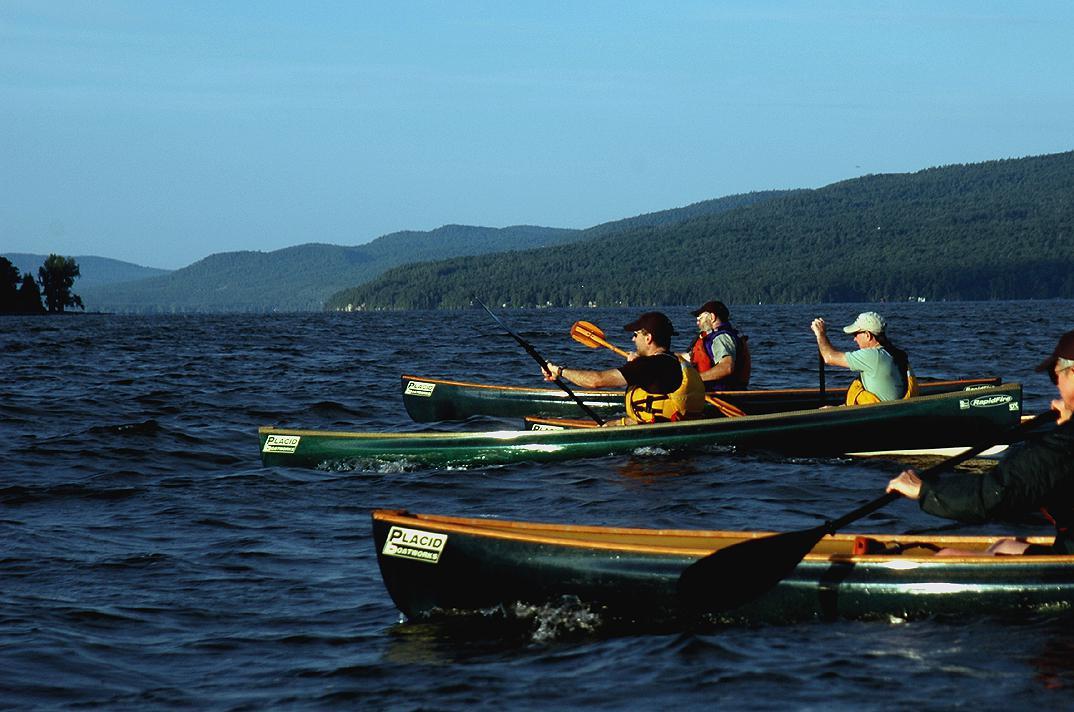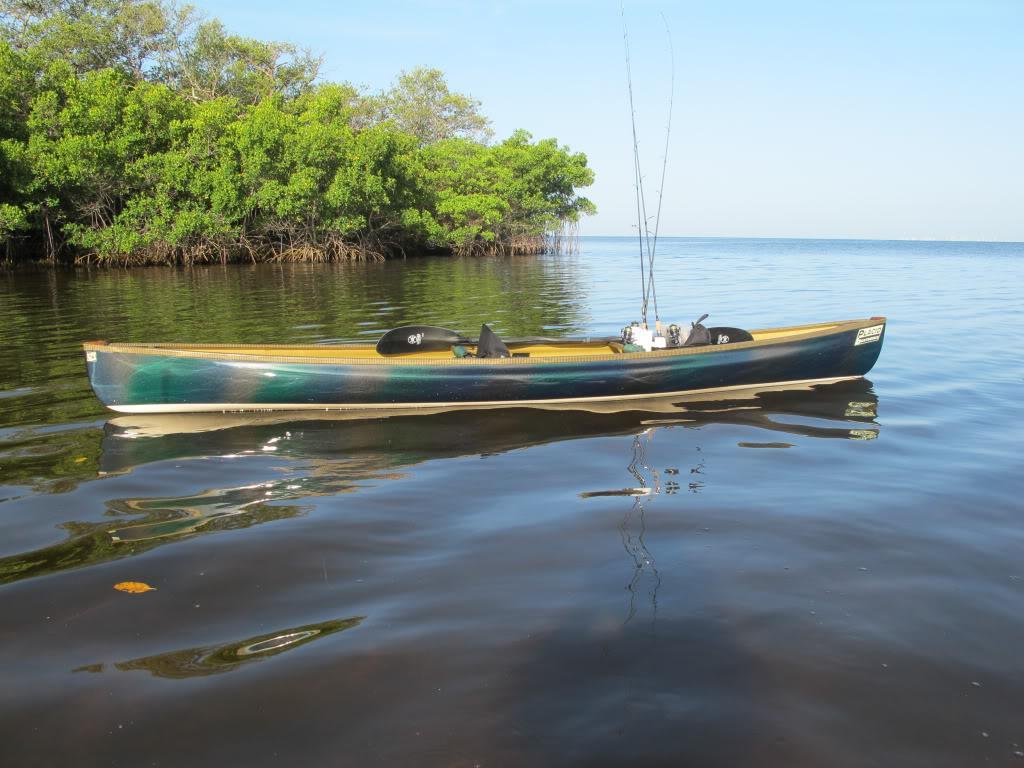The first image is the image on the left, the second image is the image on the right. For the images displayed, is the sentence "One image shows multiple canoes with rowers in them heading leftward, and the other image features a single riderless canoe containing fishing poles floating on the water." factually correct? Answer yes or no. Yes. The first image is the image on the left, the second image is the image on the right. Assess this claim about the two images: "There is exactly one canoe without anyone in it.". Correct or not? Answer yes or no. Yes. 